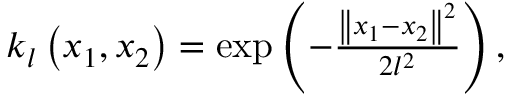<formula> <loc_0><loc_0><loc_500><loc_500>\begin{array} { r } { k _ { l } \left ( x _ { 1 } , x _ { 2 } \right ) = \exp \left ( - \frac { \left \| x _ { 1 } - x _ { 2 } \right \| ^ { 2 } } { 2 l ^ { 2 } } \right ) , } \end{array}</formula> 